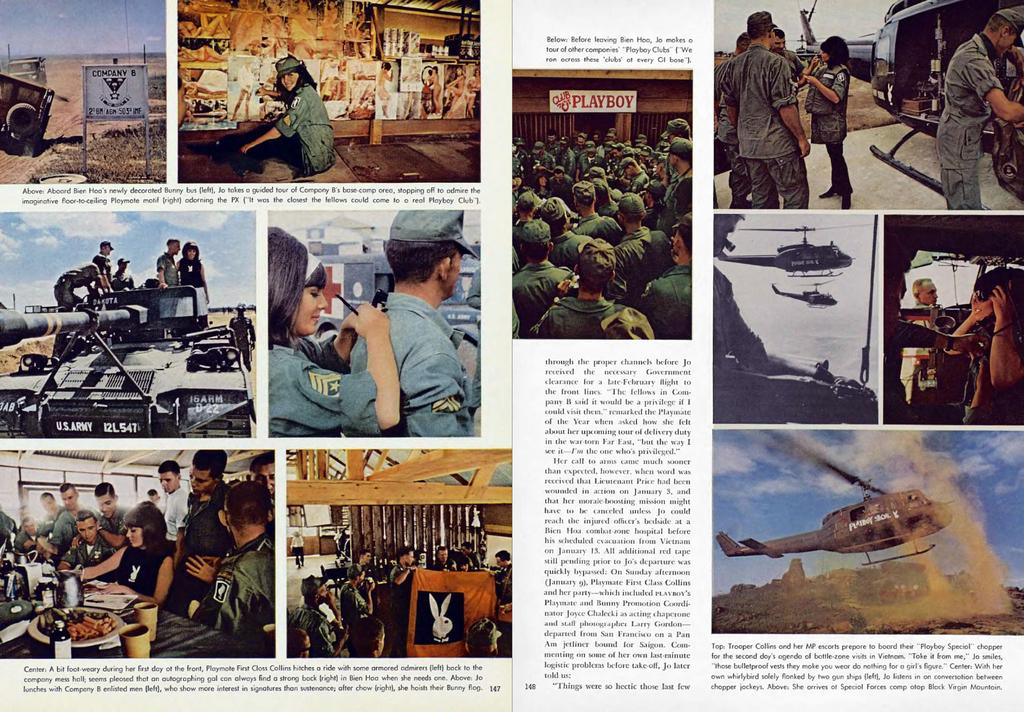<image>
Create a compact narrative representing the image presented. A magazine photo showing the front of Club Playboy is in a spread with several other photos of army-related things. 